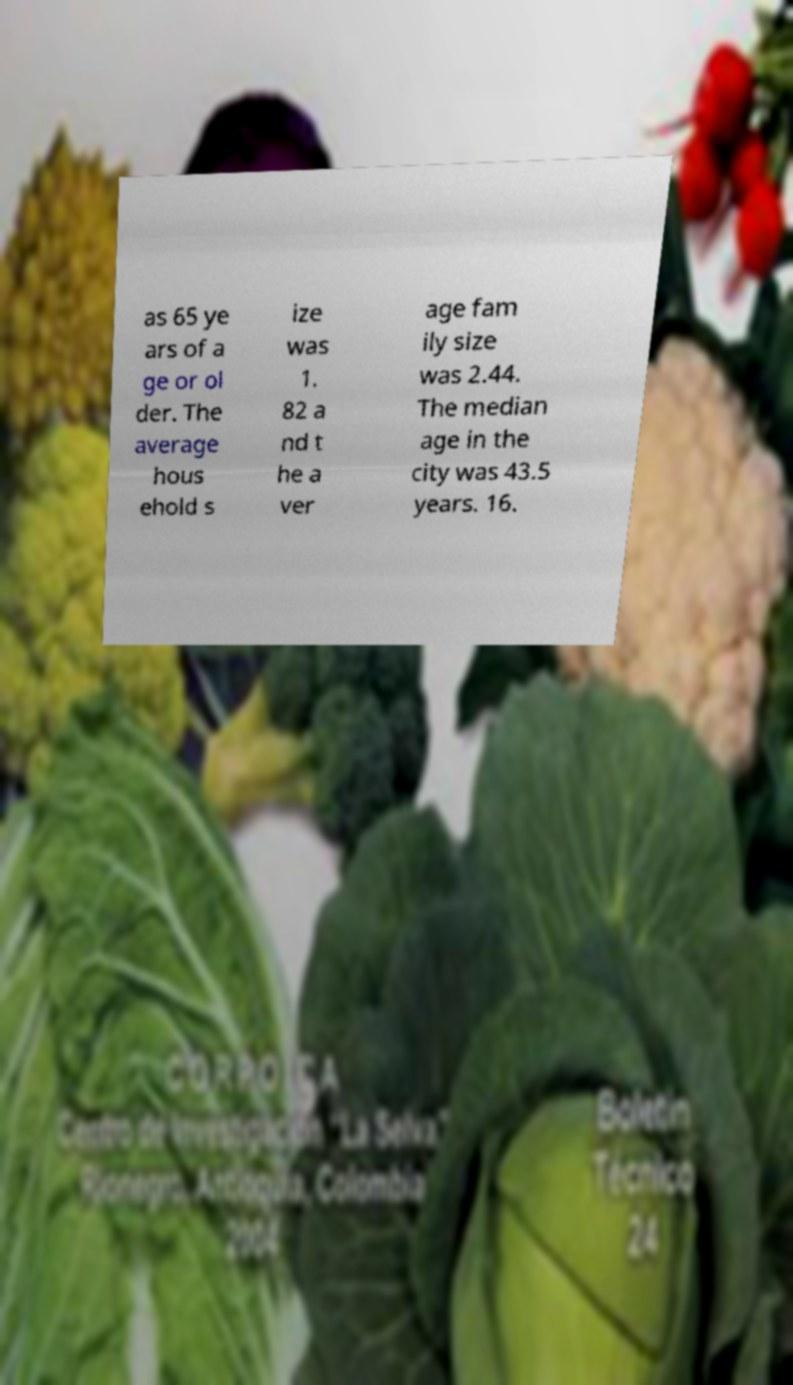Could you extract and type out the text from this image? as 65 ye ars of a ge or ol der. The average hous ehold s ize was 1. 82 a nd t he a ver age fam ily size was 2.44. The median age in the city was 43.5 years. 16. 